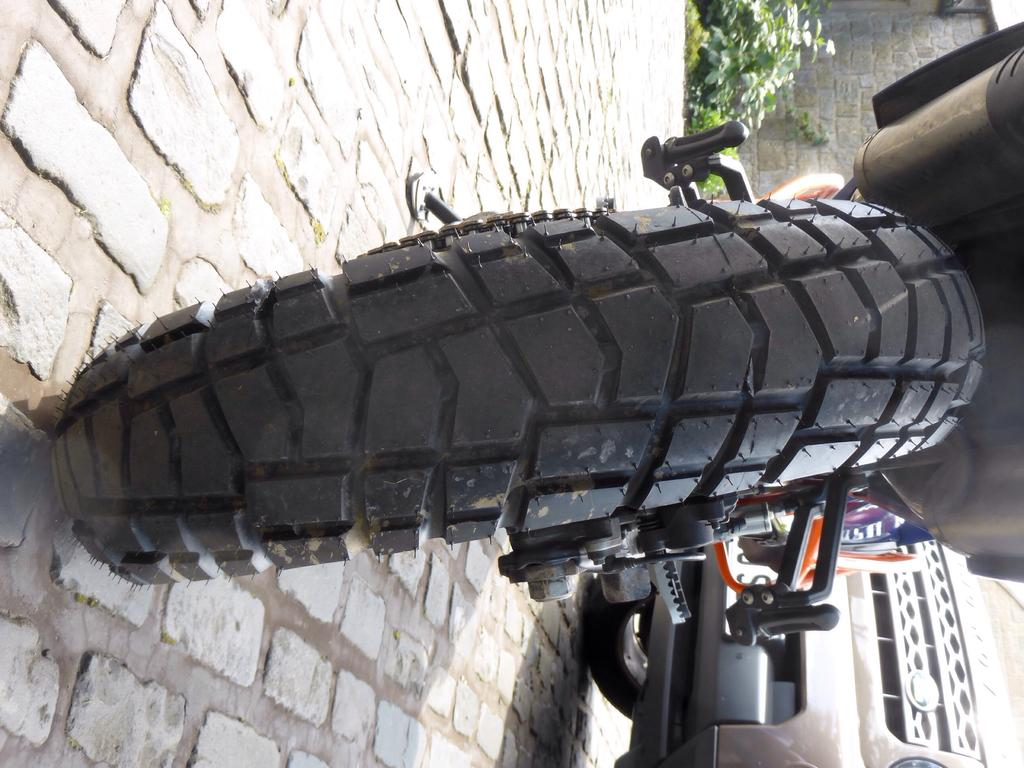What is the main object in the image? There is a motorbike tyre in the image. What is located in front of the motorbike? There is a car and plants in front of the motorbike. What type of structure is visible in the image? There is a wall in the image. What grade does the art on the wall receive in the image? There is no art or grading system present in the image. 